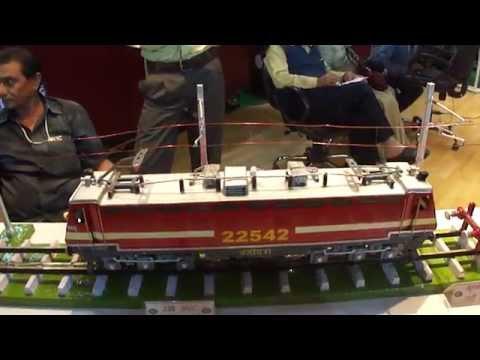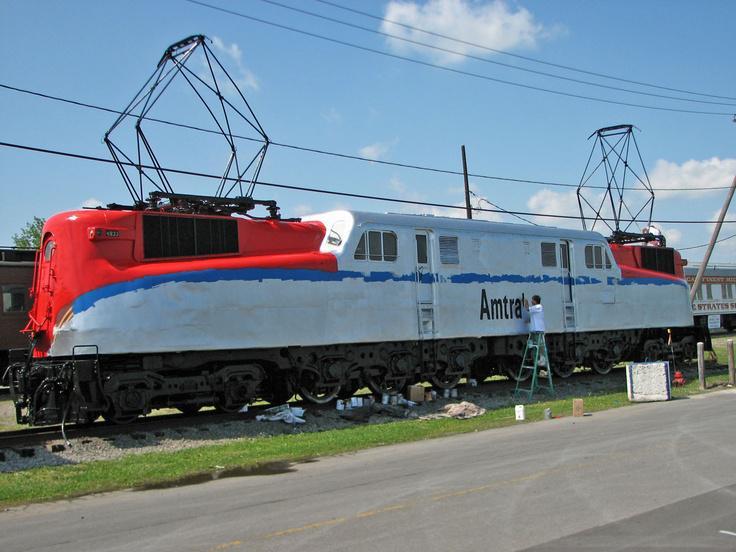The first image is the image on the left, the second image is the image on the right. Considering the images on both sides, is "Power lines can be seen above the train in the image on the right." valid? Answer yes or no. Yes. 